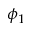<formula> <loc_0><loc_0><loc_500><loc_500>\phi _ { 1 }</formula> 